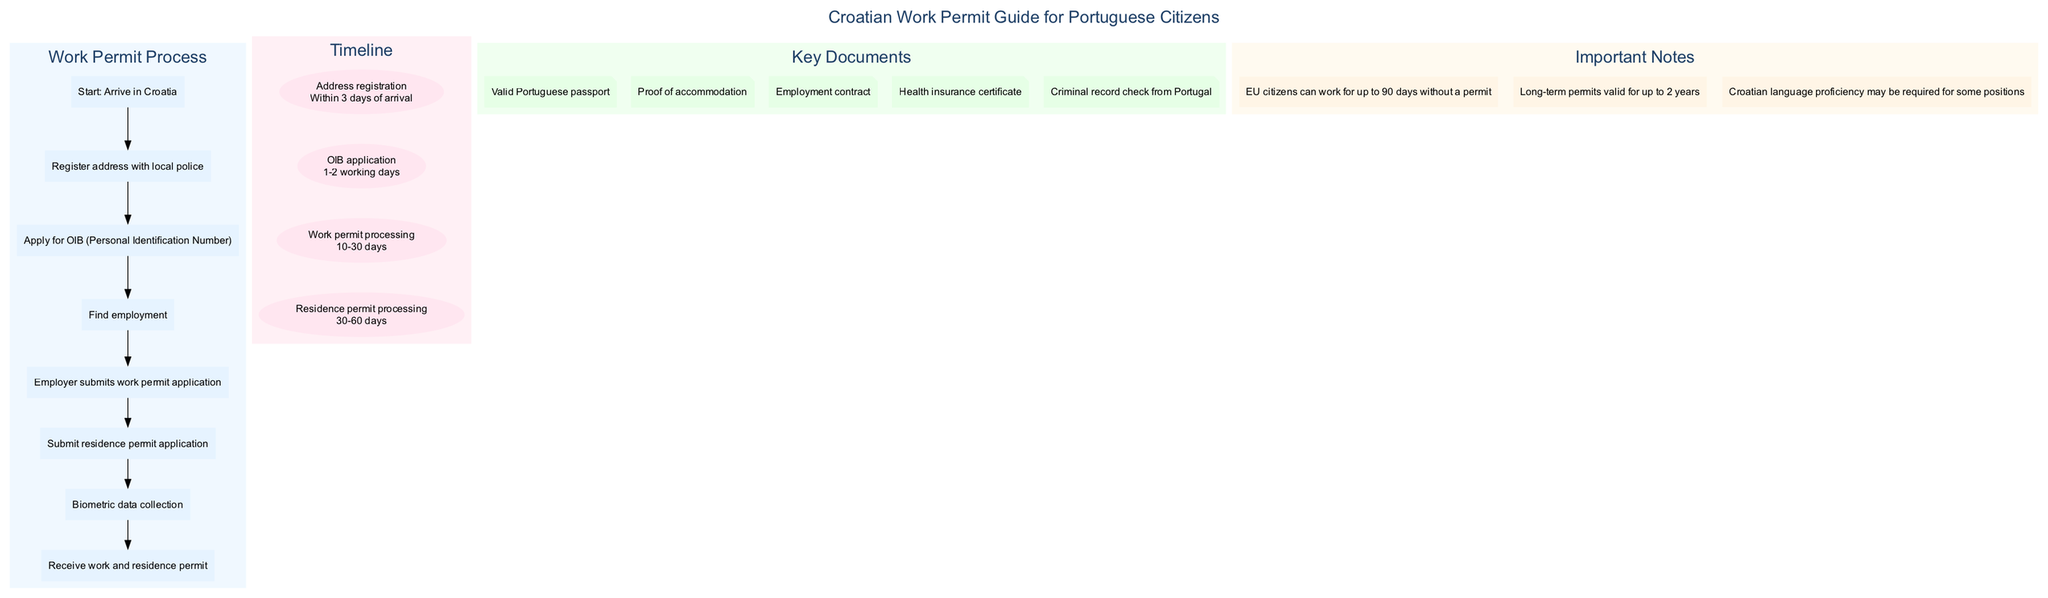What is the first step after arriving in Croatia? The diagram indicates that the first step after arriving in Croatia is to "Register address with local police". This is clearly labeled in the flowchart as the first action taken in the process.
Answer: Register address with local police How long does the OIB application take? The timeline section specifies that the OIB application duration is "1-2 working days". By referring to the corresponding event in the timeline, it is straightforward to find this information.
Answer: 1-2 working days How many steps are there in the work permit process? In the flowchart, there are 7 steps listed for the work permit process, starting from "Start: Arrive in Croatia" and ending with "Receive work and residence permit". Counting these steps gives us a total of 7.
Answer: 7 What document is required for proof of accommodation? The key documents section of the diagram lists "Proof of accommodation" as one of the necessary documents for obtaining a work permit. This is a direct reference from that category.
Answer: Proof of accommodation What is the maximum duration for long-term work permits? The important notes section mentions that "Long-term permits valid for up to 2 years". This information can be found under the key insights provided in the diagram.
Answer: 2 years What happens after finding employment? According to the flowchart, after finding employment, the next step is for the "Employer submits work permit application". This progression indicates the sequence in which the actions must occur.
Answer: Employer submits work permit application What is the total processing time range for a residence permit? The timeline states that the duration for residence permit processing ranges from "30-60 days". Thus, by referring to this timeframe in the timeline, we can determine the answer.
Answer: 30-60 days Which language proficiency might be required for some positions? The important notes section highlights that "Croatian language proficiency may be required for some positions". This note is crucial for understanding job requirements in Croatia.
Answer: Croatian language proficiency What is the last step in the work permit process? The flowchart clearly concludes with the step "Receive work and residence permit", which signifies the completion of the entire process. This last step directly answers the question.
Answer: Receive work and residence permit 